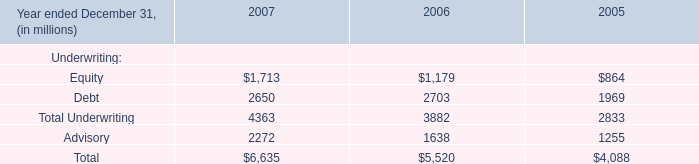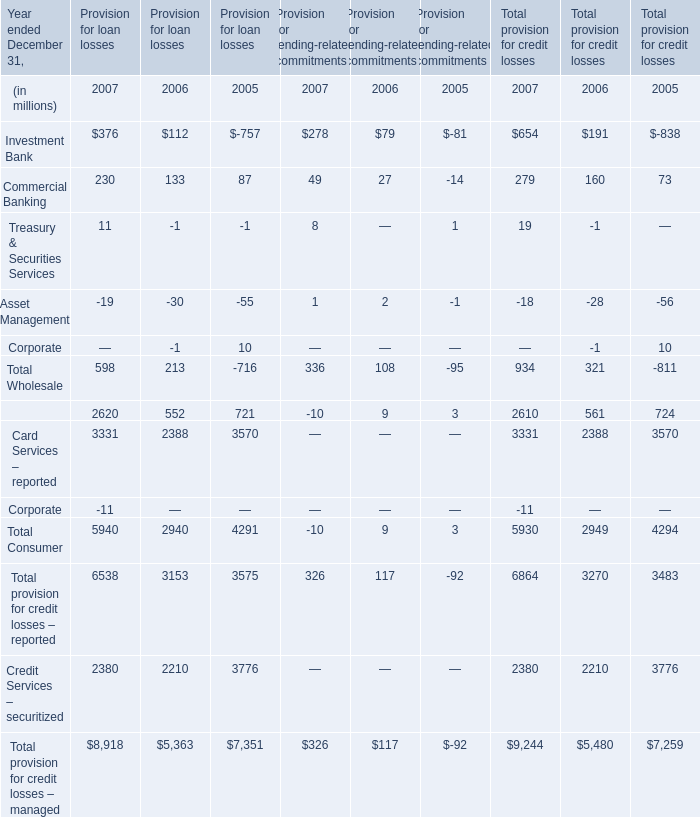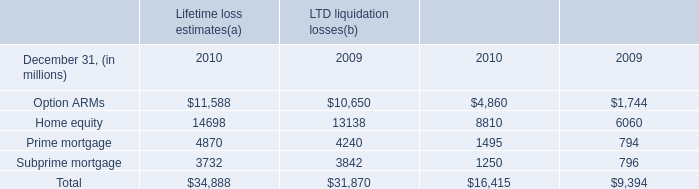What is the total amount of Credit Services – securitized of Provision for loan losses 2005, Home equity of LTD liquidation losses 2009, and Option ARMs of LTD liquidation losses 2009 ? 
Computations: ((3776.0 + 6060.0) + 10650.0)
Answer: 20486.0. 